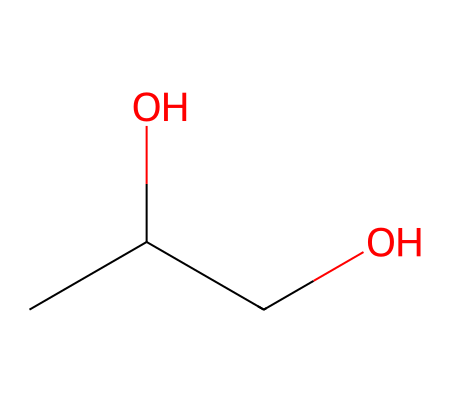What is the common name of the compound represented by this SMILES? The SMILES structure corresponds to a compound with two hydroxyl (–OH) groups attached to a three-carbon chain, which is known as propylene glycol.
Answer: propylene glycol How many carbon atoms are in propylene glycol? By analyzing the SMILES, there are three carbon (C) atoms in the structure, as indicated by the three 'C' representations before the hydroxyl groups.
Answer: 3 How many hydroxyl groups are present in propylene glycol? The SMILES shows two 'O' atoms which represent the hydroxyl (–OH) groups, indicating that propylene glycol has two hydroxyl groups.
Answer: 2 What is the functional group present in propylene glycol? The presence of the hydroxyl (–OH) groups in the structure indicates that the functional group is alcohol, as alcohols are characterized by these groups.
Answer: alcohol Is propylene glycol a polar or non-polar solvent? The presence of hydroxyl groups creates partial charges due to oxygen's electronegativity, making propylene glycol a polar solvent.
Answer: polar Does propylene glycol have a high or low viscosity compared to water? Propylene glycol is generally more viscous than water, as it has a higher molecular weight and more hydrogen bonding due to its hydroxyl groups.
Answer: high What is the main use of propylene glycol in e-cigarette liquids? Propylene glycol is primarily used as a base or carrier in e-cigarette liquids, providing throat hit and helping dissolve flavorings.
Answer: base 